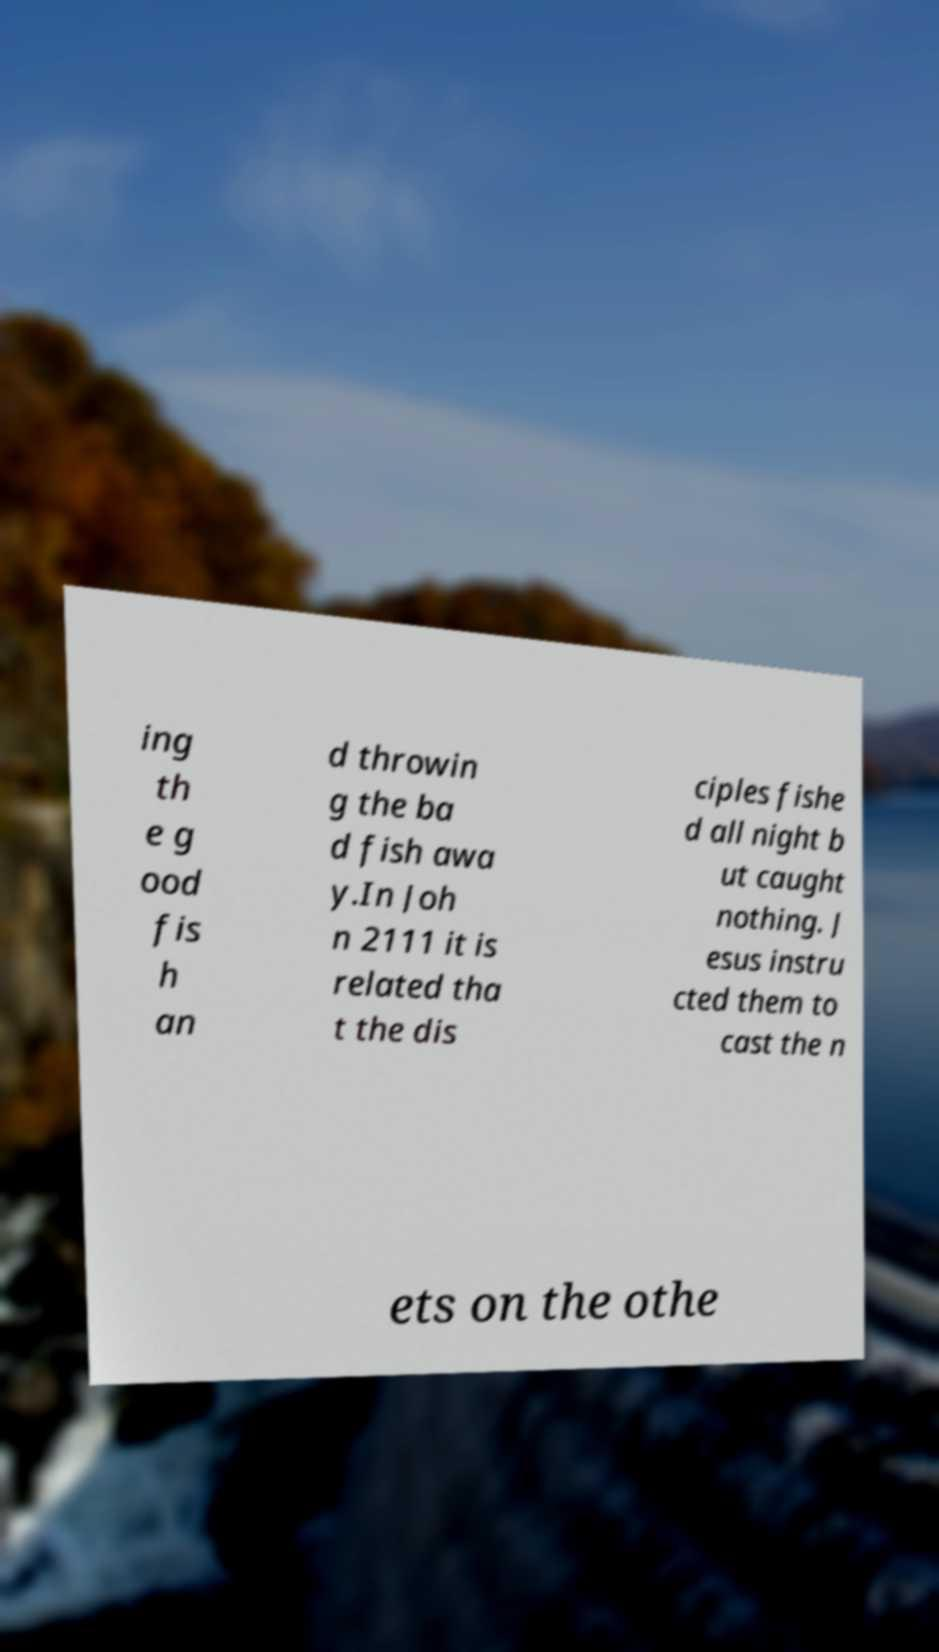There's text embedded in this image that I need extracted. Can you transcribe it verbatim? ing th e g ood fis h an d throwin g the ba d fish awa y.In Joh n 2111 it is related tha t the dis ciples fishe d all night b ut caught nothing. J esus instru cted them to cast the n ets on the othe 